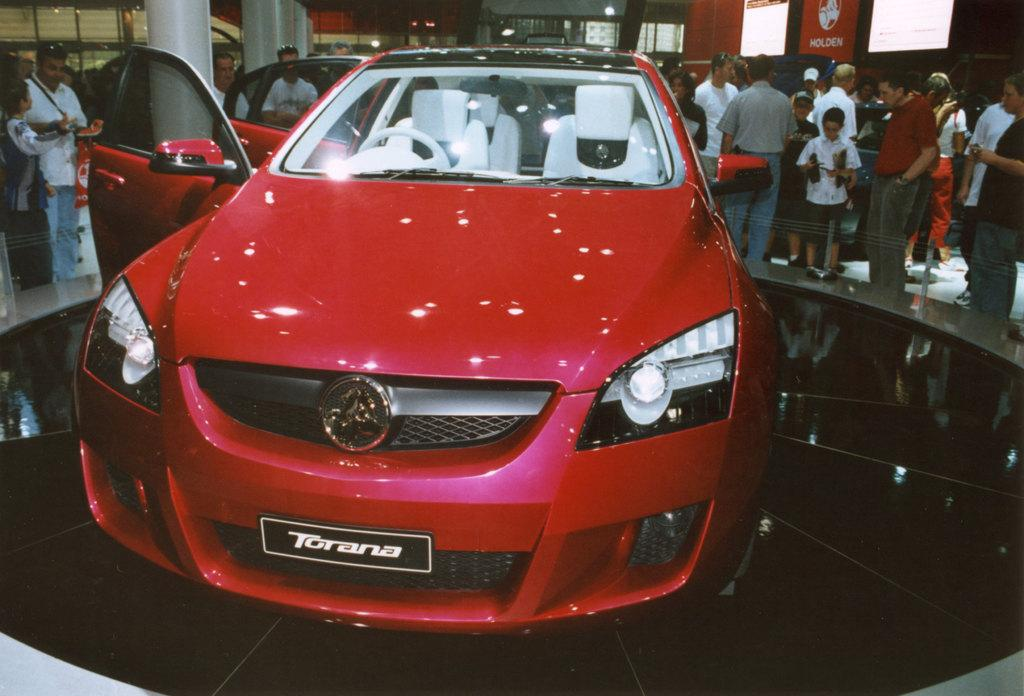What is the main subject of the image? There is a car in the image. Can you describe the car's appearance? The car is red. What is the position of the car door? The car door is open. What can be seen behind the car? There is a group of people behind the car. What are the people doing in the image? The people are standing. What type of office can be seen in the background of the image? There is no office present in the image; it features a car with an open door and a group of people standing behind it. 